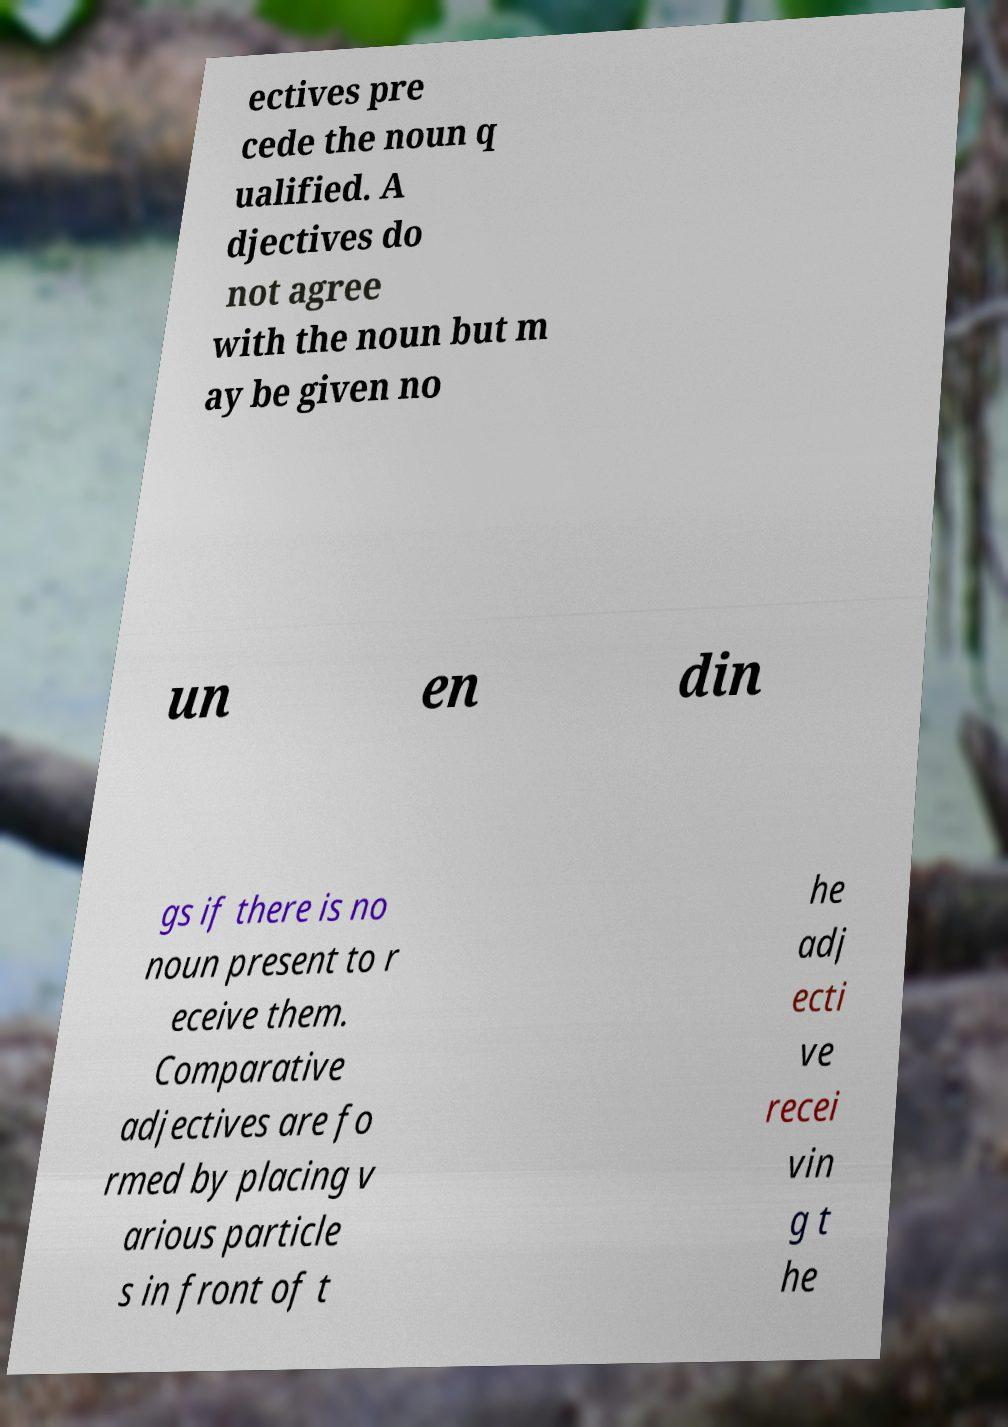Please identify and transcribe the text found in this image. ectives pre cede the noun q ualified. A djectives do not agree with the noun but m ay be given no un en din gs if there is no noun present to r eceive them. Comparative adjectives are fo rmed by placing v arious particle s in front of t he adj ecti ve recei vin g t he 